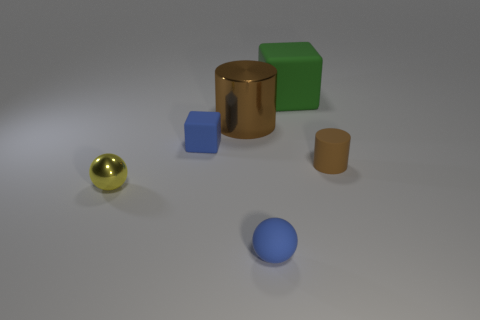What is the color of the sphere that is made of the same material as the tiny brown cylinder?
Make the answer very short. Blue. There is a small rubber thing that is the same color as the tiny matte ball; what shape is it?
Ensure brevity in your answer.  Cube. There is another brown object that is the same shape as the brown rubber object; what is its material?
Offer a terse response. Metal. There is a metal sphere that is the same size as the matte sphere; what is its color?
Give a very brief answer. Yellow. The rubber thing that is the same color as the matte ball is what size?
Offer a terse response. Small. There is a big thing in front of the rubber thing behind the matte block that is in front of the large green thing; what is its color?
Keep it short and to the point. Brown. How many other objects are the same shape as the large shiny thing?
Offer a very short reply. 1. There is a object right of the large rubber cube; what shape is it?
Give a very brief answer. Cylinder. Is there a brown cylinder that is behind the small blue object behind the tiny brown cylinder?
Give a very brief answer. Yes. There is a small thing that is on the left side of the rubber sphere and behind the tiny yellow metal thing; what color is it?
Provide a short and direct response. Blue. 